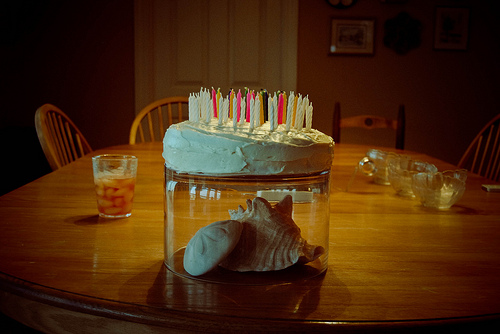<image>
Can you confirm if the cake is above the seashell? Yes. The cake is positioned above the seashell in the vertical space, higher up in the scene. 